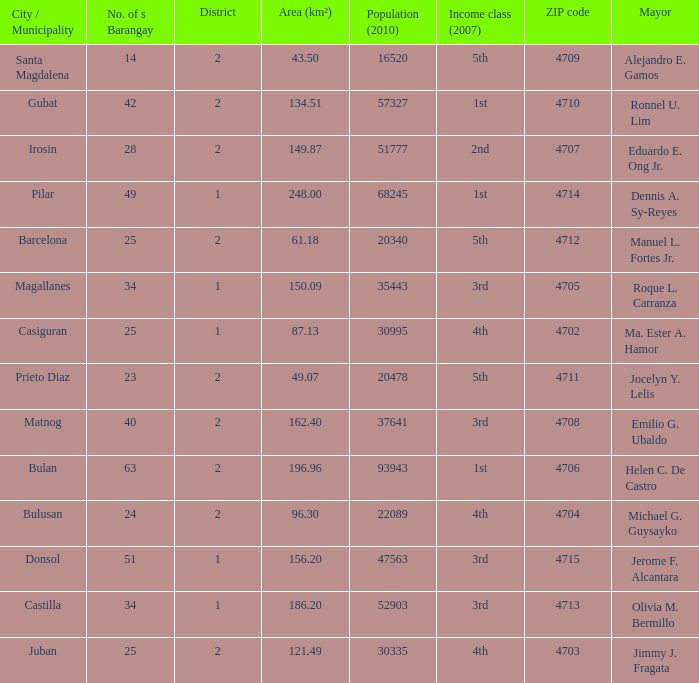What are all the vicinity (km²) where profits magnificence (2007) is 2nd 149.87. 